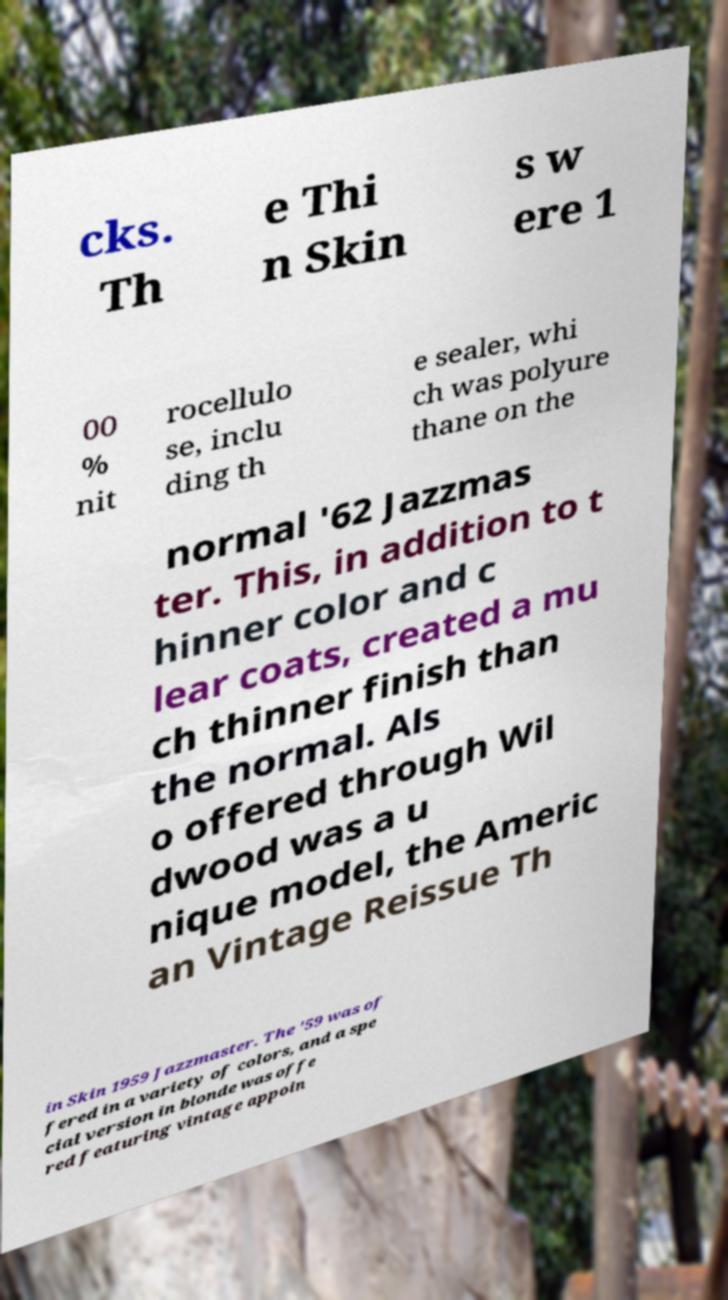I need the written content from this picture converted into text. Can you do that? cks. Th e Thi n Skin s w ere 1 00 % nit rocellulo se, inclu ding th e sealer, whi ch was polyure thane on the normal '62 Jazzmas ter. This, in addition to t hinner color and c lear coats, created a mu ch thinner finish than the normal. Als o offered through Wil dwood was a u nique model, the Americ an Vintage Reissue Th in Skin 1959 Jazzmaster. The '59 was of fered in a variety of colors, and a spe cial version in blonde was offe red featuring vintage appoin 